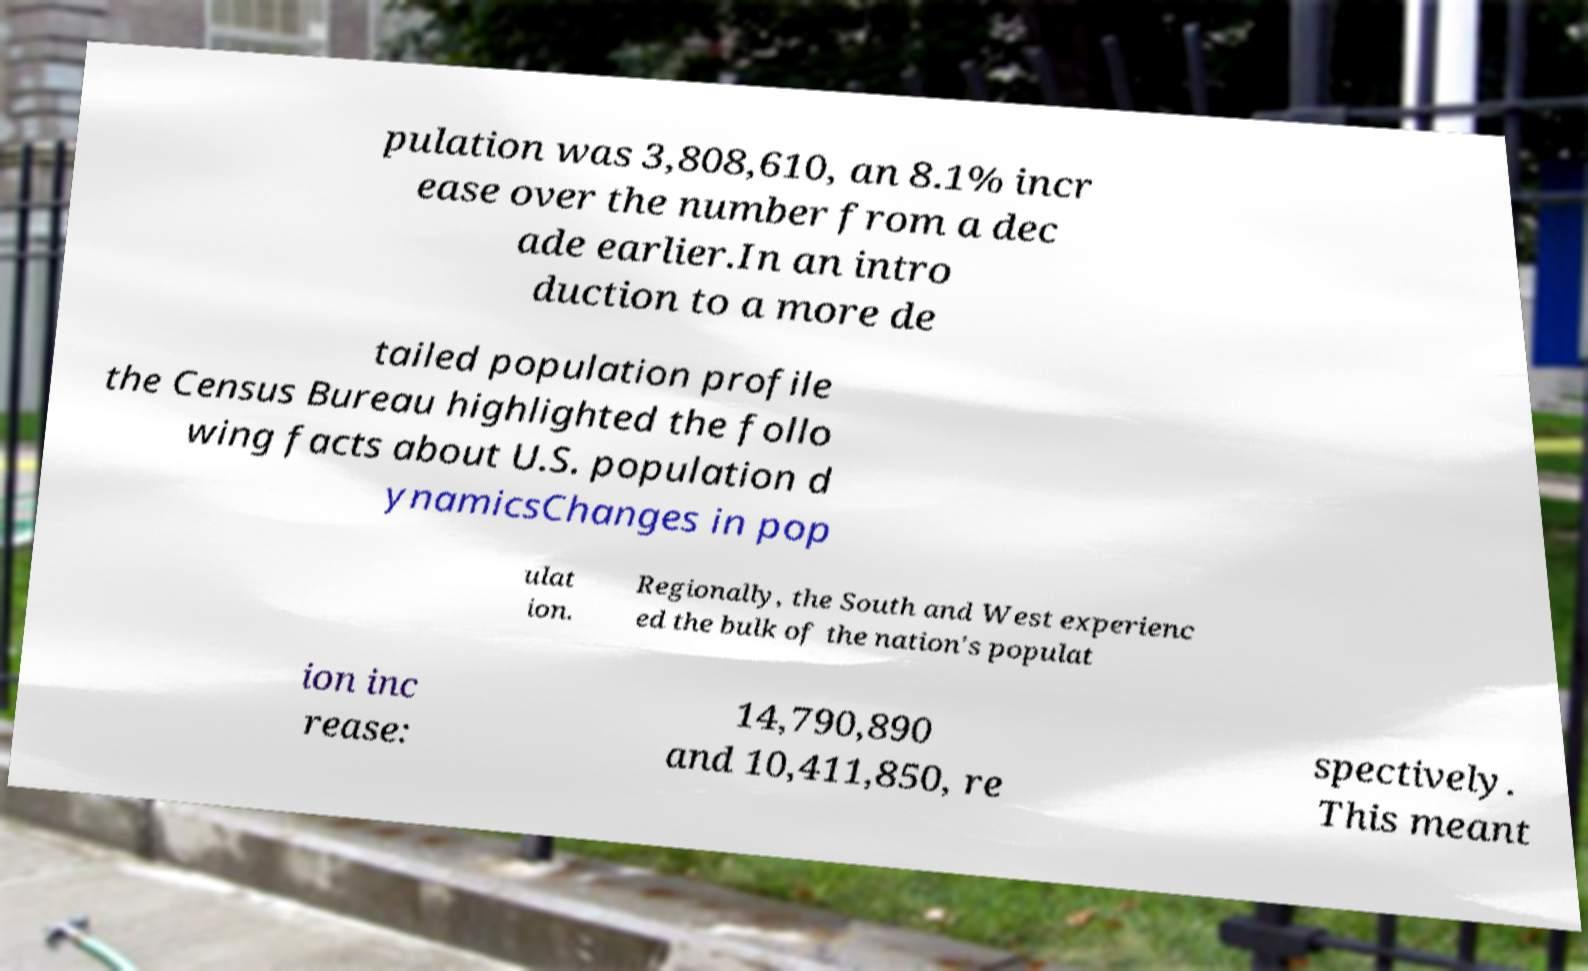Can you read and provide the text displayed in the image?This photo seems to have some interesting text. Can you extract and type it out for me? pulation was 3,808,610, an 8.1% incr ease over the number from a dec ade earlier.In an intro duction to a more de tailed population profile the Census Bureau highlighted the follo wing facts about U.S. population d ynamicsChanges in pop ulat ion. Regionally, the South and West experienc ed the bulk of the nation's populat ion inc rease: 14,790,890 and 10,411,850, re spectively. This meant 